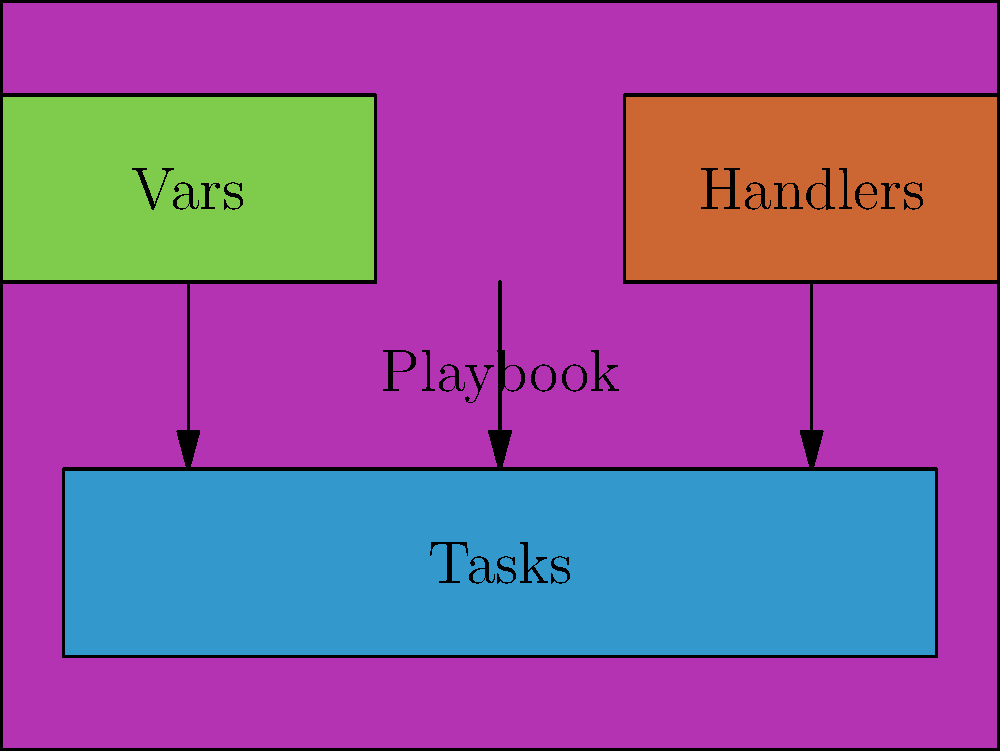In the diagram representing an Ansible playbook structure, which component is directly connected to both the "Vars" and "Handlers" sections? To answer this question, let's analyze the diagram step-by-step:

1. The diagram shows a high-level structure of an Ansible playbook.
2. There are four main components illustrated:
   a) The outer box labeled "Playbook" (in purple)
   b) A box labeled "Vars" (in green) on the upper left
   c) A box labeled "Handlers" (in orange) on the upper right
   d) A box labeled "Tasks" (in blue) at the bottom

3. We can see arrows connecting different components:
   - An arrow from "Vars" to "Tasks"
   - An arrow from "Handlers" to "Tasks"
   - An arrow from the main "Playbook" box to "Tasks"

4. The question asks which component is directly connected to both "Vars" and "Handlers".

5. Following the arrows, we can see that both "Vars" and "Handlers" have arrows pointing to the "Tasks" section.

6. Therefore, the "Tasks" component is the one directly connected to both "Vars" and "Handlers".

This structure reflects how an Ansible playbook typically works:
- Variables (Vars) can be used within tasks
- Handlers can be triggered by tasks
- Tasks are the central component where the main actions of the playbook are defined
Answer: Tasks 